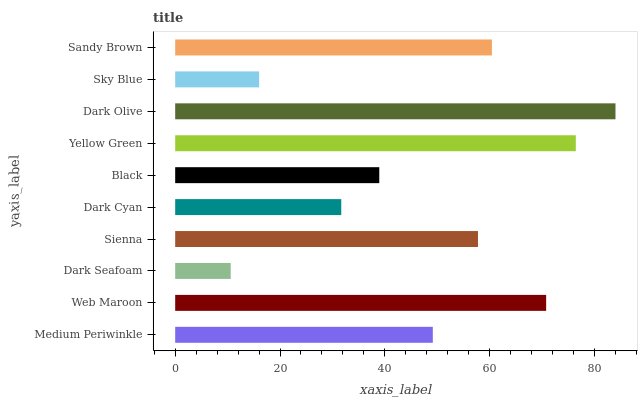Is Dark Seafoam the minimum?
Answer yes or no. Yes. Is Dark Olive the maximum?
Answer yes or no. Yes. Is Web Maroon the minimum?
Answer yes or no. No. Is Web Maroon the maximum?
Answer yes or no. No. Is Web Maroon greater than Medium Periwinkle?
Answer yes or no. Yes. Is Medium Periwinkle less than Web Maroon?
Answer yes or no. Yes. Is Medium Periwinkle greater than Web Maroon?
Answer yes or no. No. Is Web Maroon less than Medium Periwinkle?
Answer yes or no. No. Is Sienna the high median?
Answer yes or no. Yes. Is Medium Periwinkle the low median?
Answer yes or no. Yes. Is Dark Cyan the high median?
Answer yes or no. No. Is Web Maroon the low median?
Answer yes or no. No. 